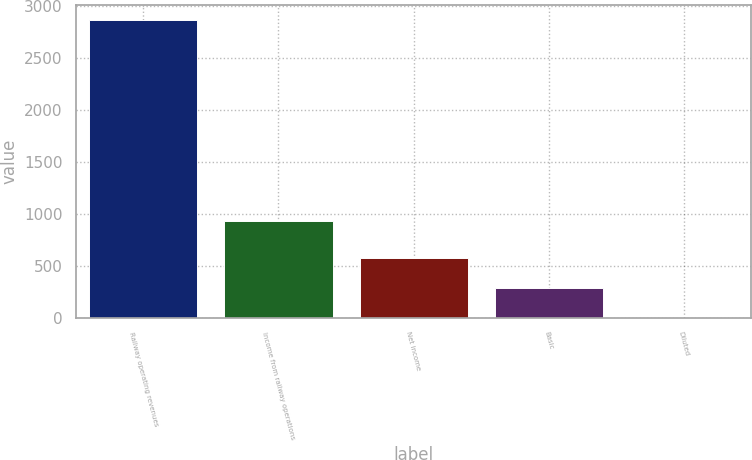<chart> <loc_0><loc_0><loc_500><loc_500><bar_chart><fcel>Railway operating revenues<fcel>Income from railway operations<fcel>Net income<fcel>Basic<fcel>Diluted<nl><fcel>2874<fcel>934<fcel>576.08<fcel>288.84<fcel>1.6<nl></chart> 